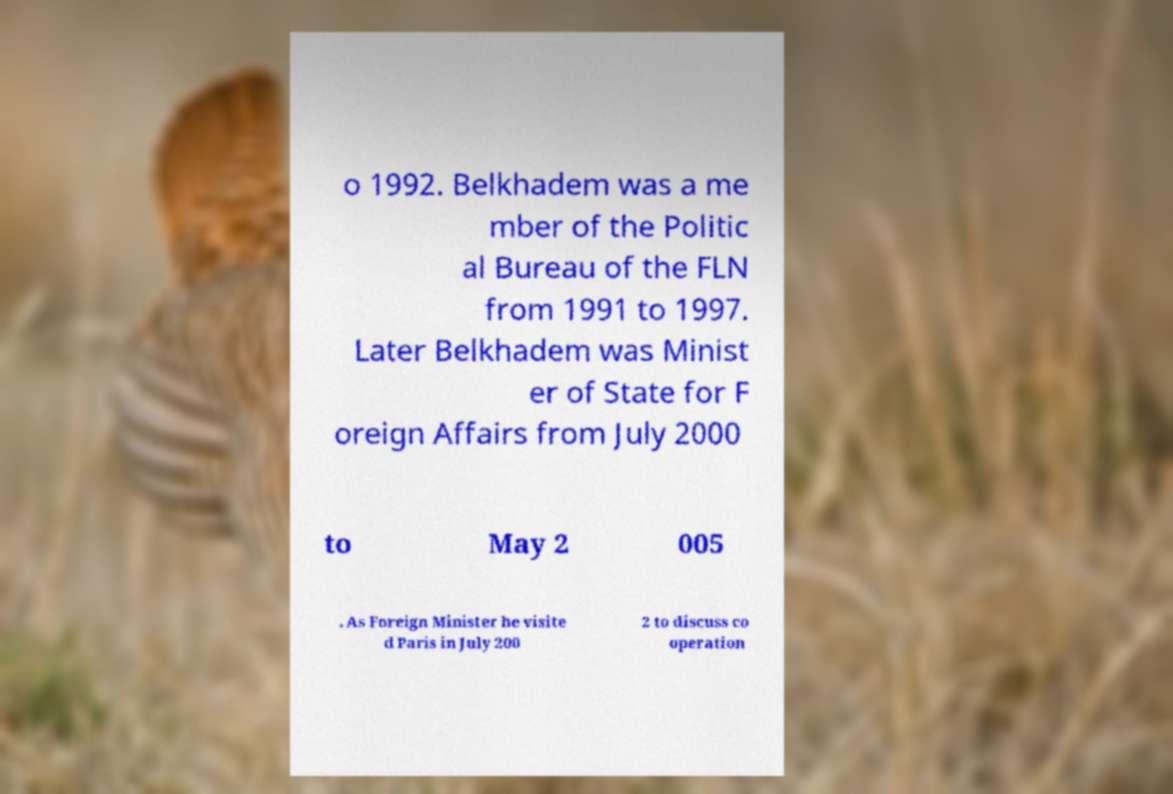For documentation purposes, I need the text within this image transcribed. Could you provide that? o 1992. Belkhadem was a me mber of the Politic al Bureau of the FLN from 1991 to 1997. Later Belkhadem was Minist er of State for F oreign Affairs from July 2000 to May 2 005 . As Foreign Minister he visite d Paris in July 200 2 to discuss co operation 